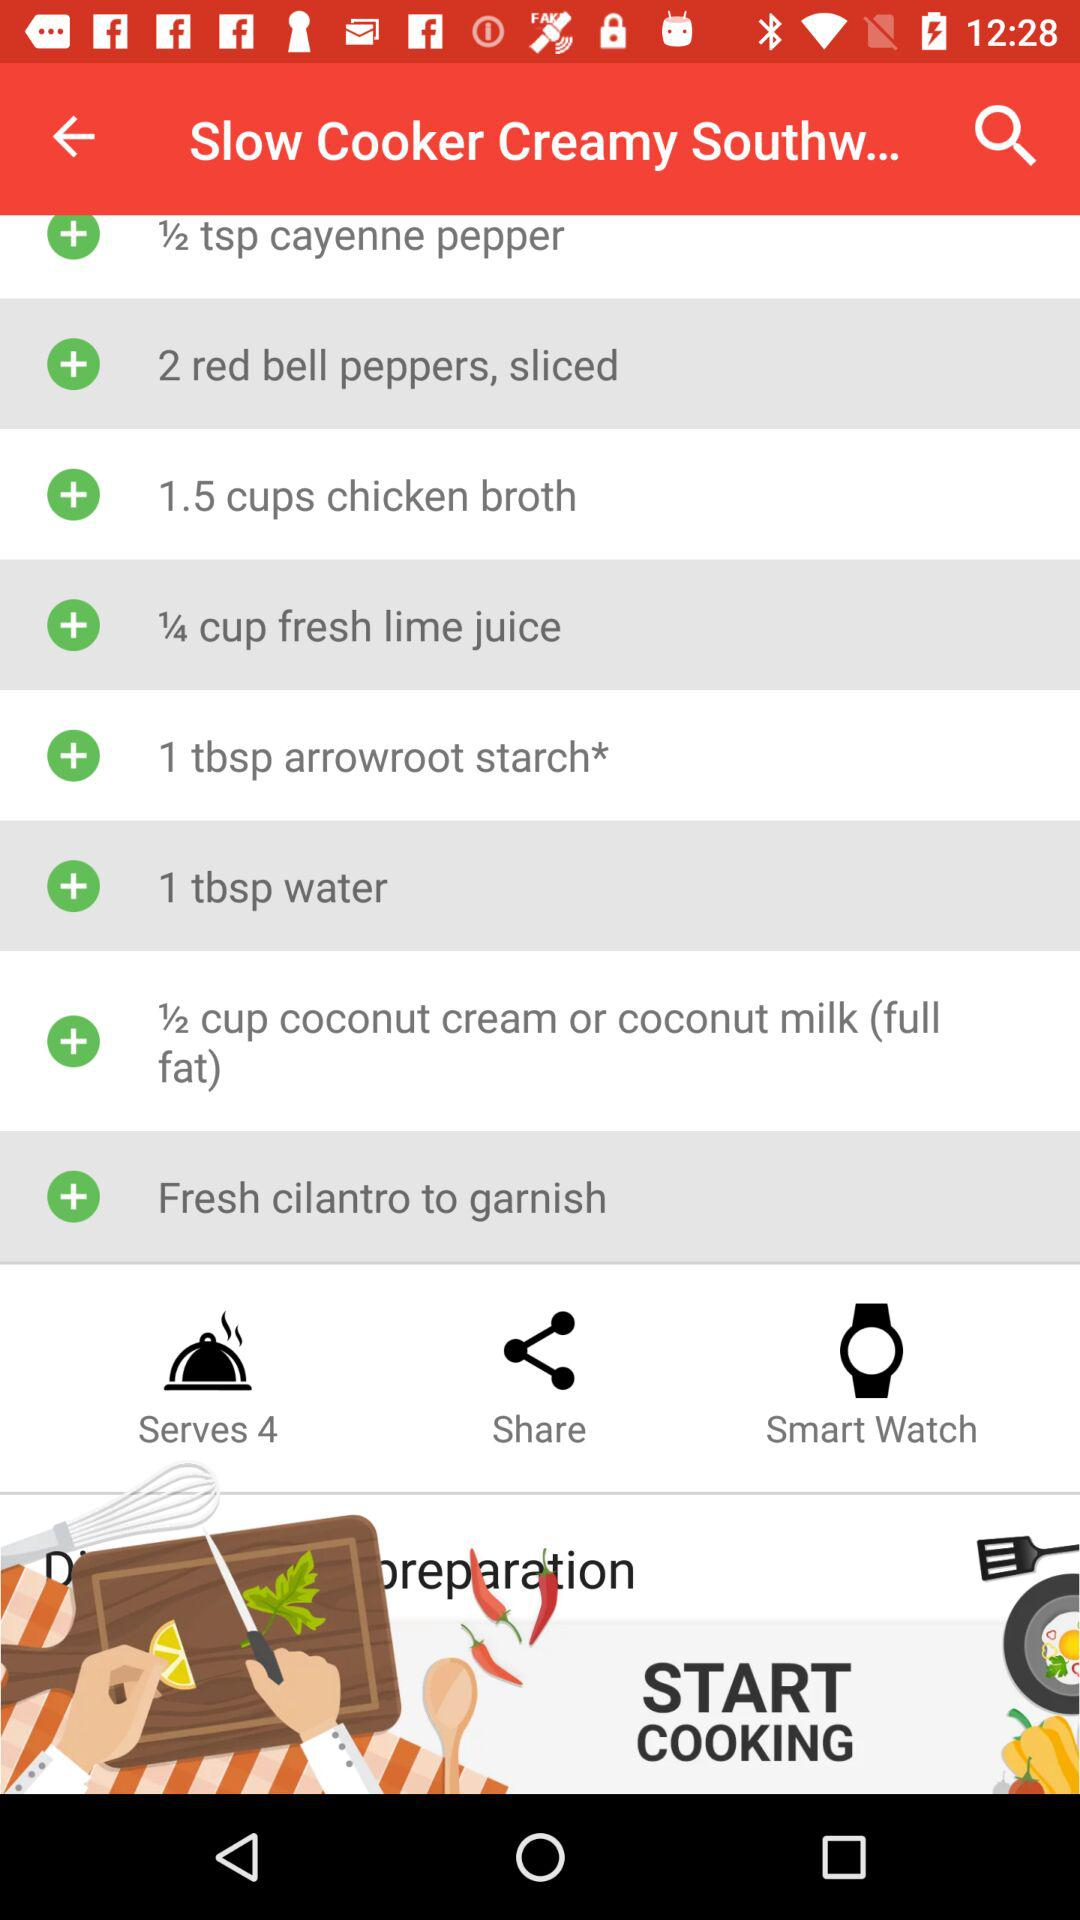What is the name of the dish? The name of the dish is "Slow Cooker Creamy Southw...". 